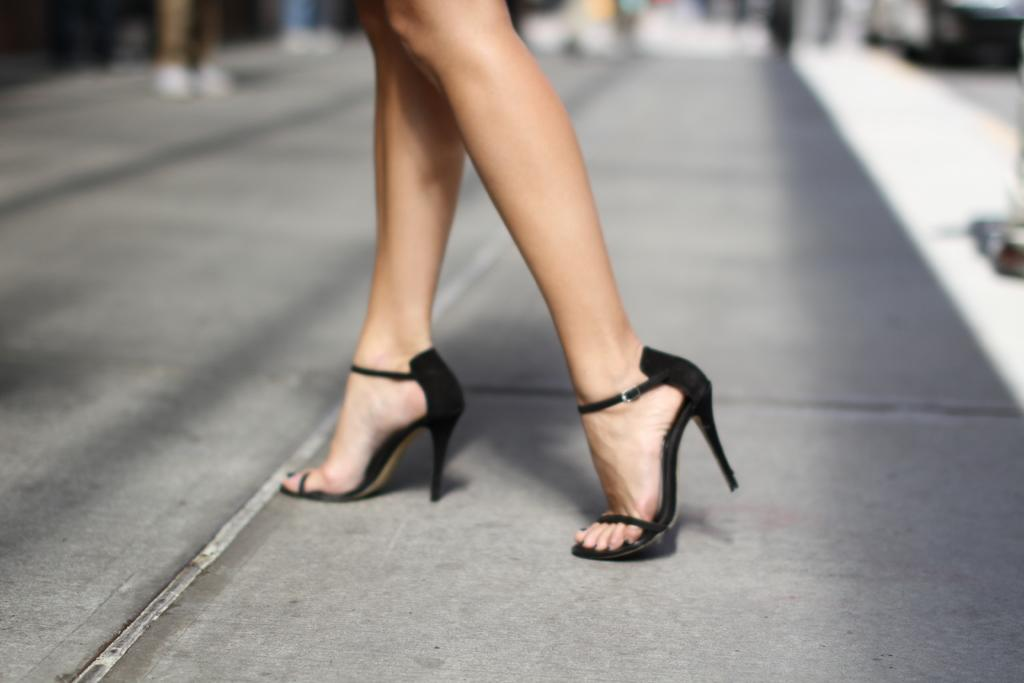Who is the main subject in the image? There is a woman in the center of the image. What is the woman doing in the image? The woman is walking. What is the surface on which the woman is walking? There is a walkway at the bottom of the image. What can be seen in the background of the image? There are some objects in the background of the image. What type of writing can be seen on the woman's shirt in the image? There is no writing visible on the woman's shirt in the image. 